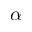Convert formula to latex. <formula><loc_0><loc_0><loc_500><loc_500>\alpha</formula> 